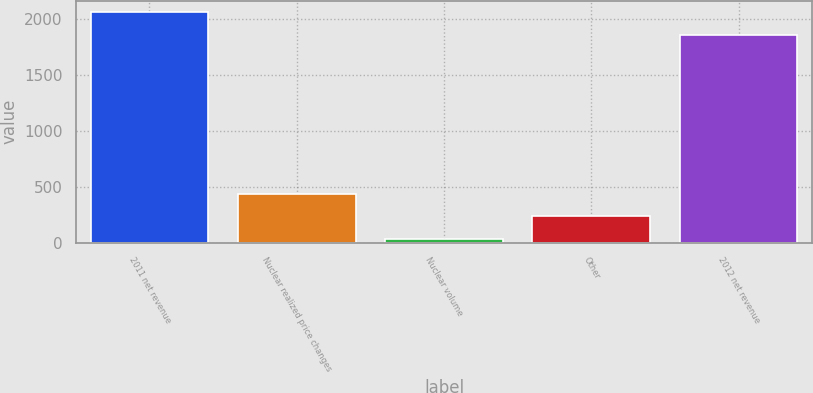Convert chart. <chart><loc_0><loc_0><loc_500><loc_500><bar_chart><fcel>2011 net revenue<fcel>Nuclear realized price changes<fcel>Nuclear volume<fcel>Other<fcel>2012 net revenue<nl><fcel>2055.2<fcel>435.4<fcel>33<fcel>234.2<fcel>1854<nl></chart> 